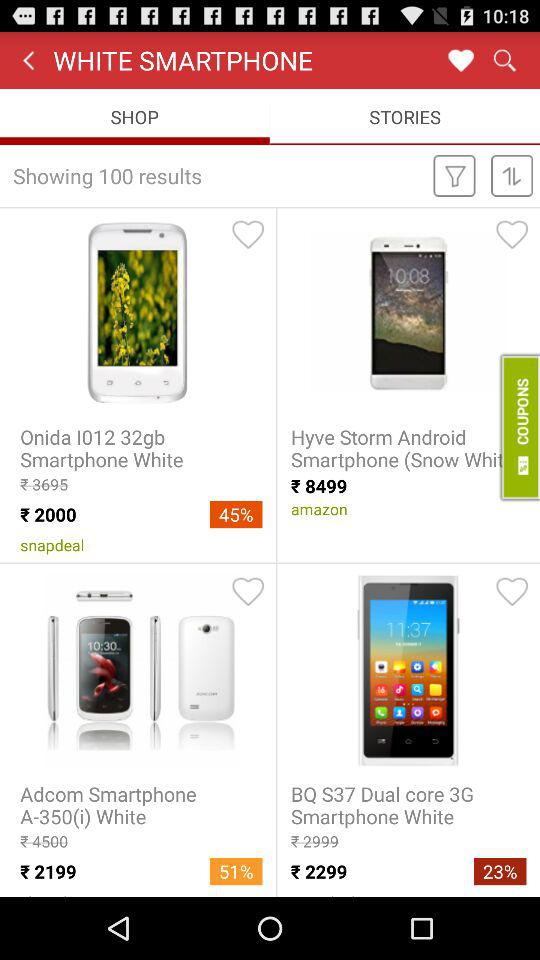What is the price of "Hyve Storm"? The price of "Hyve Storm" is 8499 rupees. 